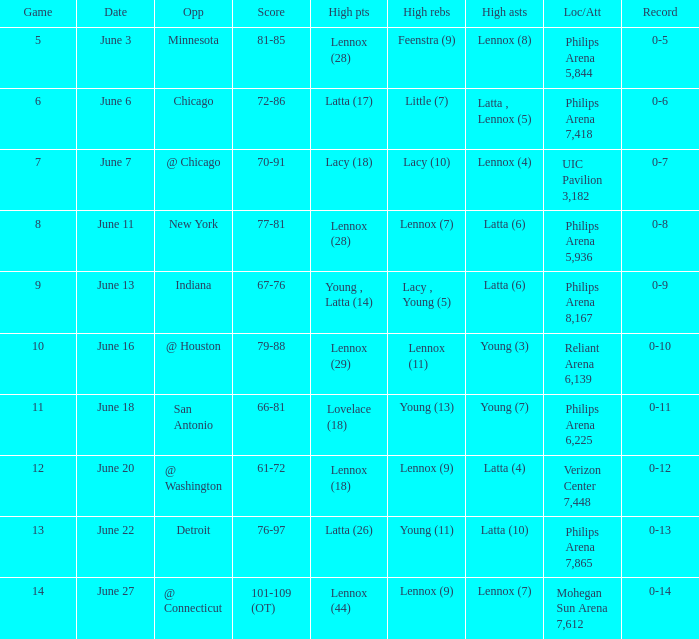Who made the highest assist in the game that scored 79-88? Young (3). 